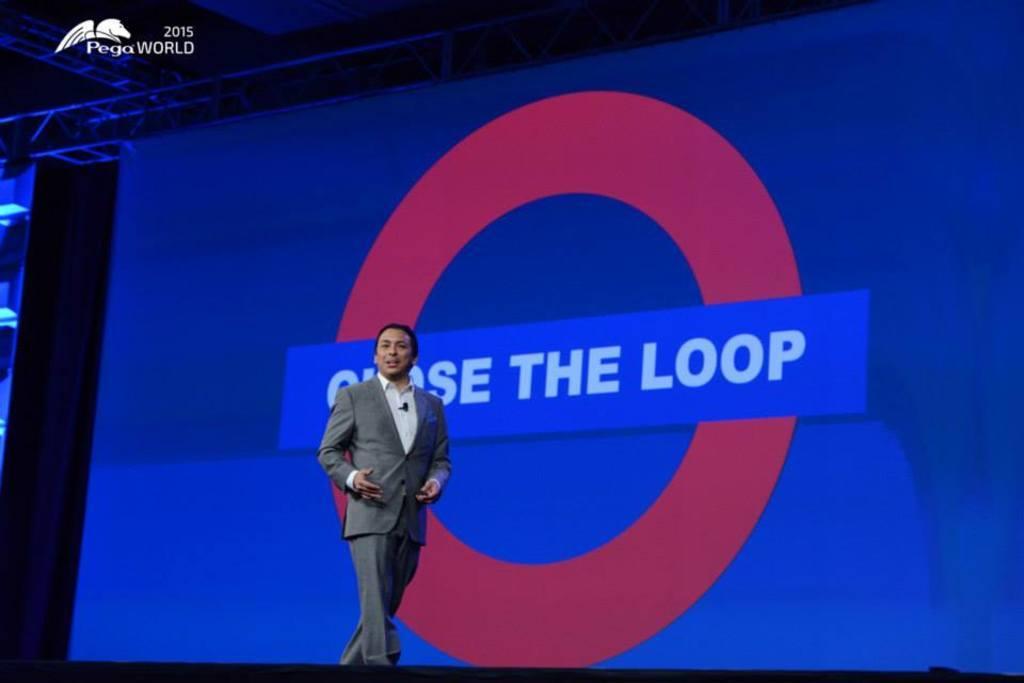Please provide a concise description of this image. In this image there is a person standing, there is a screen and a watermark on the image. 